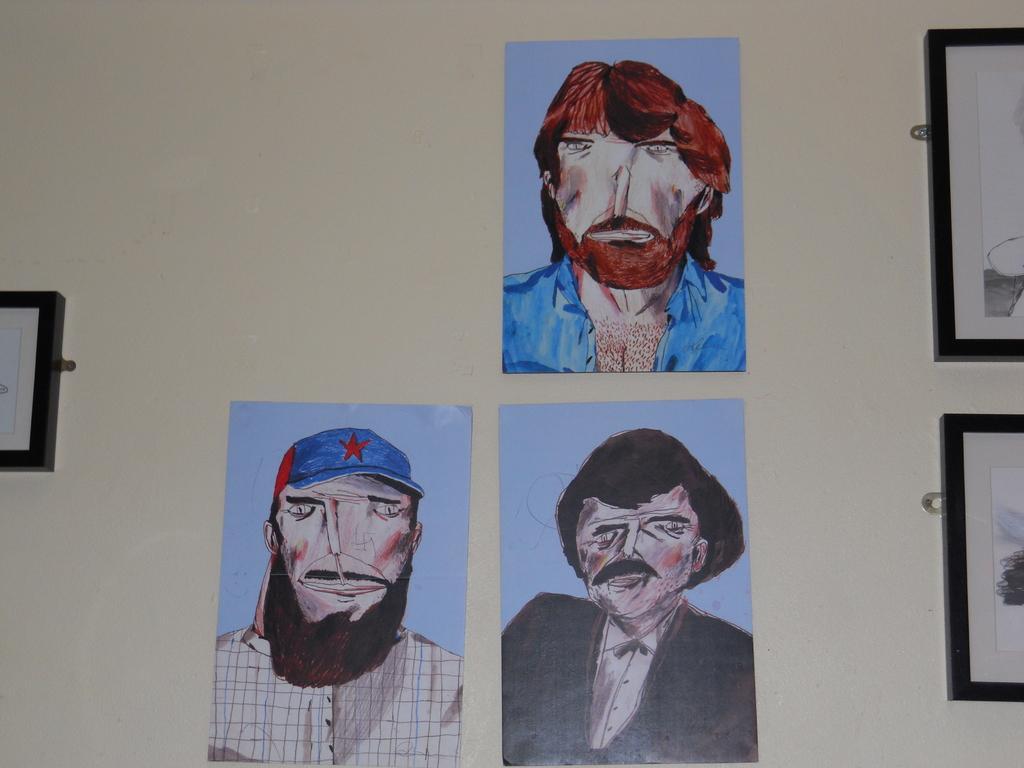Could you give a brief overview of what you see in this image? In this image we can see sketches and frames placed on the wall. 